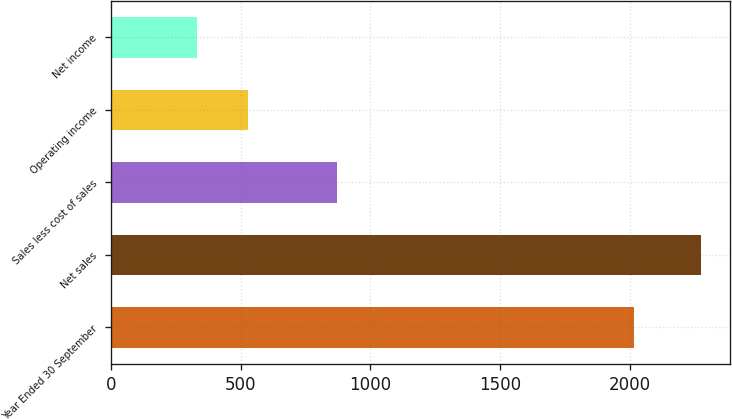Convert chart. <chart><loc_0><loc_0><loc_500><loc_500><bar_chart><fcel>Year Ended 30 September<fcel>Net sales<fcel>Sales less cost of sales<fcel>Operating income<fcel>Net income<nl><fcel>2016<fcel>2271.6<fcel>871.5<fcel>527.85<fcel>334.1<nl></chart> 